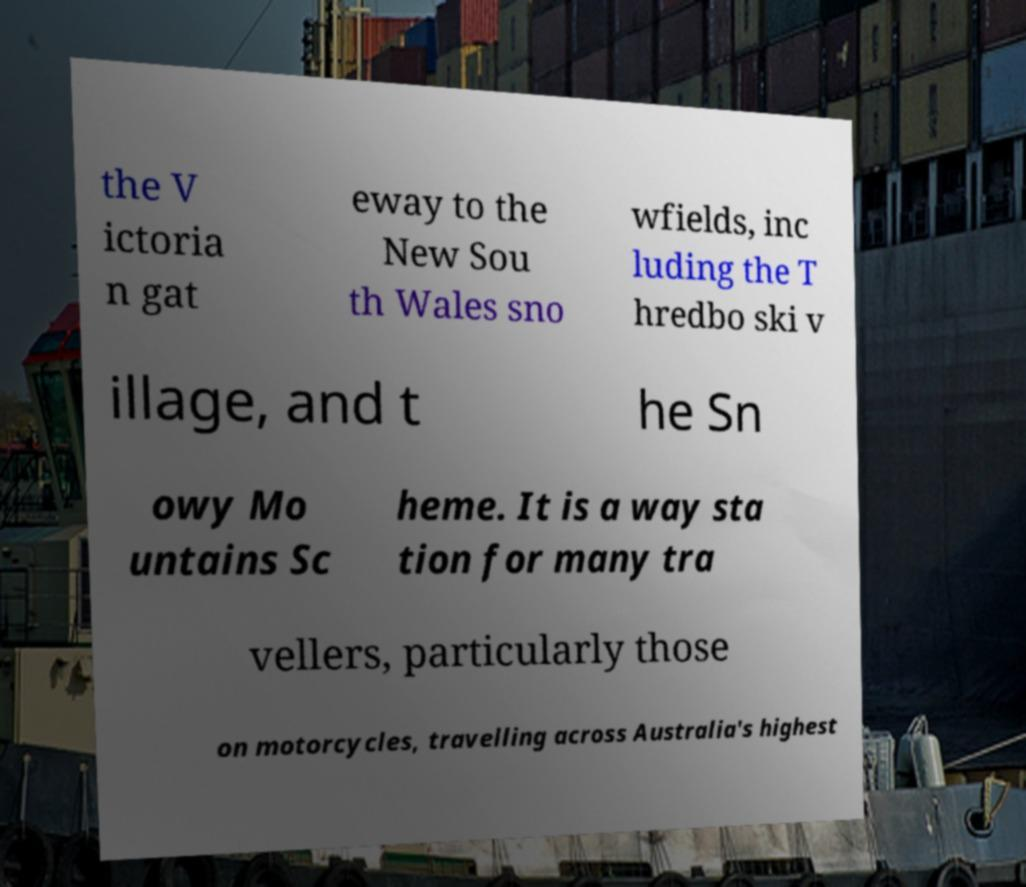Could you assist in decoding the text presented in this image and type it out clearly? the V ictoria n gat eway to the New Sou th Wales sno wfields, inc luding the T hredbo ski v illage, and t he Sn owy Mo untains Sc heme. It is a way sta tion for many tra vellers, particularly those on motorcycles, travelling across Australia's highest 